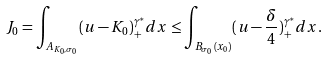Convert formula to latex. <formula><loc_0><loc_0><loc_500><loc_500>J _ { 0 } = \int _ { A _ { K _ { 0 } , \sigma _ { 0 } } } ( u - K _ { 0 } ) _ { + } ^ { \gamma ^ { * } } d x \leq \int _ { B _ { \sigma _ { 0 } } ( x _ { 0 } ) } ( u - \frac { \delta } { 4 } ) _ { + } ^ { \gamma ^ { * } } d x .</formula> 